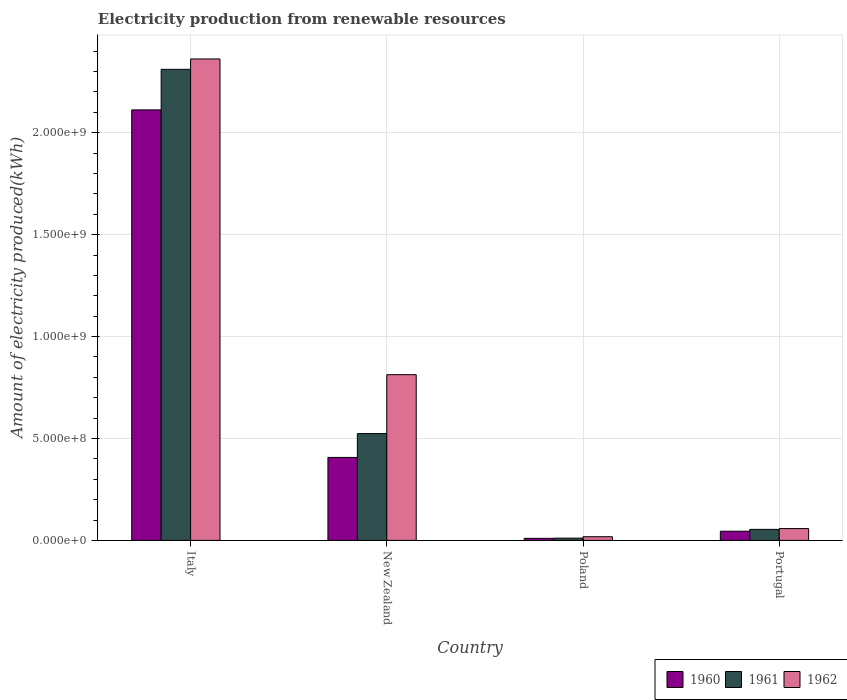How many groups of bars are there?
Offer a terse response. 4. Are the number of bars per tick equal to the number of legend labels?
Make the answer very short. Yes. How many bars are there on the 3rd tick from the left?
Keep it short and to the point. 3. How many bars are there on the 1st tick from the right?
Make the answer very short. 3. What is the label of the 2nd group of bars from the left?
Offer a very short reply. New Zealand. What is the amount of electricity produced in 1960 in Italy?
Give a very brief answer. 2.11e+09. Across all countries, what is the maximum amount of electricity produced in 1961?
Offer a very short reply. 2.31e+09. Across all countries, what is the minimum amount of electricity produced in 1962?
Your response must be concise. 1.80e+07. In which country was the amount of electricity produced in 1961 minimum?
Your answer should be very brief. Poland. What is the total amount of electricity produced in 1960 in the graph?
Your answer should be compact. 2.57e+09. What is the difference between the amount of electricity produced in 1960 in Italy and that in New Zealand?
Give a very brief answer. 1.70e+09. What is the difference between the amount of electricity produced in 1962 in Portugal and the amount of electricity produced in 1960 in Italy?
Keep it short and to the point. -2.05e+09. What is the average amount of electricity produced in 1961 per country?
Keep it short and to the point. 7.25e+08. What is the difference between the amount of electricity produced of/in 1960 and amount of electricity produced of/in 1961 in Italy?
Your answer should be compact. -1.99e+08. In how many countries, is the amount of electricity produced in 1961 greater than 800000000 kWh?
Your response must be concise. 1. What is the ratio of the amount of electricity produced in 1960 in New Zealand to that in Poland?
Ensure brevity in your answer.  40.7. Is the difference between the amount of electricity produced in 1960 in Poland and Portugal greater than the difference between the amount of electricity produced in 1961 in Poland and Portugal?
Provide a short and direct response. Yes. What is the difference between the highest and the second highest amount of electricity produced in 1961?
Your answer should be very brief. 1.79e+09. What is the difference between the highest and the lowest amount of electricity produced in 1961?
Provide a succinct answer. 2.30e+09. How many bars are there?
Your answer should be compact. 12. Are all the bars in the graph horizontal?
Your response must be concise. No. Are the values on the major ticks of Y-axis written in scientific E-notation?
Give a very brief answer. Yes. Does the graph contain any zero values?
Give a very brief answer. No. How are the legend labels stacked?
Make the answer very short. Horizontal. What is the title of the graph?
Make the answer very short. Electricity production from renewable resources. Does "2002" appear as one of the legend labels in the graph?
Your response must be concise. No. What is the label or title of the Y-axis?
Make the answer very short. Amount of electricity produced(kWh). What is the Amount of electricity produced(kWh) in 1960 in Italy?
Your answer should be very brief. 2.11e+09. What is the Amount of electricity produced(kWh) of 1961 in Italy?
Your answer should be very brief. 2.31e+09. What is the Amount of electricity produced(kWh) in 1962 in Italy?
Your answer should be compact. 2.36e+09. What is the Amount of electricity produced(kWh) of 1960 in New Zealand?
Give a very brief answer. 4.07e+08. What is the Amount of electricity produced(kWh) in 1961 in New Zealand?
Provide a short and direct response. 5.24e+08. What is the Amount of electricity produced(kWh) in 1962 in New Zealand?
Provide a succinct answer. 8.13e+08. What is the Amount of electricity produced(kWh) of 1960 in Poland?
Offer a very short reply. 1.00e+07. What is the Amount of electricity produced(kWh) of 1961 in Poland?
Provide a short and direct response. 1.10e+07. What is the Amount of electricity produced(kWh) in 1962 in Poland?
Offer a very short reply. 1.80e+07. What is the Amount of electricity produced(kWh) of 1960 in Portugal?
Make the answer very short. 4.50e+07. What is the Amount of electricity produced(kWh) of 1961 in Portugal?
Provide a short and direct response. 5.40e+07. What is the Amount of electricity produced(kWh) of 1962 in Portugal?
Your answer should be very brief. 5.80e+07. Across all countries, what is the maximum Amount of electricity produced(kWh) in 1960?
Offer a terse response. 2.11e+09. Across all countries, what is the maximum Amount of electricity produced(kWh) in 1961?
Offer a terse response. 2.31e+09. Across all countries, what is the maximum Amount of electricity produced(kWh) of 1962?
Make the answer very short. 2.36e+09. Across all countries, what is the minimum Amount of electricity produced(kWh) of 1961?
Offer a very short reply. 1.10e+07. Across all countries, what is the minimum Amount of electricity produced(kWh) of 1962?
Give a very brief answer. 1.80e+07. What is the total Amount of electricity produced(kWh) in 1960 in the graph?
Make the answer very short. 2.57e+09. What is the total Amount of electricity produced(kWh) of 1961 in the graph?
Keep it short and to the point. 2.90e+09. What is the total Amount of electricity produced(kWh) of 1962 in the graph?
Offer a terse response. 3.25e+09. What is the difference between the Amount of electricity produced(kWh) of 1960 in Italy and that in New Zealand?
Your response must be concise. 1.70e+09. What is the difference between the Amount of electricity produced(kWh) in 1961 in Italy and that in New Zealand?
Provide a short and direct response. 1.79e+09. What is the difference between the Amount of electricity produced(kWh) of 1962 in Italy and that in New Zealand?
Give a very brief answer. 1.55e+09. What is the difference between the Amount of electricity produced(kWh) in 1960 in Italy and that in Poland?
Keep it short and to the point. 2.10e+09. What is the difference between the Amount of electricity produced(kWh) of 1961 in Italy and that in Poland?
Keep it short and to the point. 2.30e+09. What is the difference between the Amount of electricity produced(kWh) in 1962 in Italy and that in Poland?
Provide a short and direct response. 2.34e+09. What is the difference between the Amount of electricity produced(kWh) of 1960 in Italy and that in Portugal?
Make the answer very short. 2.07e+09. What is the difference between the Amount of electricity produced(kWh) of 1961 in Italy and that in Portugal?
Your answer should be very brief. 2.26e+09. What is the difference between the Amount of electricity produced(kWh) in 1962 in Italy and that in Portugal?
Your answer should be compact. 2.30e+09. What is the difference between the Amount of electricity produced(kWh) of 1960 in New Zealand and that in Poland?
Offer a very short reply. 3.97e+08. What is the difference between the Amount of electricity produced(kWh) in 1961 in New Zealand and that in Poland?
Your answer should be compact. 5.13e+08. What is the difference between the Amount of electricity produced(kWh) in 1962 in New Zealand and that in Poland?
Your answer should be compact. 7.95e+08. What is the difference between the Amount of electricity produced(kWh) in 1960 in New Zealand and that in Portugal?
Make the answer very short. 3.62e+08. What is the difference between the Amount of electricity produced(kWh) in 1961 in New Zealand and that in Portugal?
Keep it short and to the point. 4.70e+08. What is the difference between the Amount of electricity produced(kWh) in 1962 in New Zealand and that in Portugal?
Make the answer very short. 7.55e+08. What is the difference between the Amount of electricity produced(kWh) of 1960 in Poland and that in Portugal?
Ensure brevity in your answer.  -3.50e+07. What is the difference between the Amount of electricity produced(kWh) in 1961 in Poland and that in Portugal?
Provide a short and direct response. -4.30e+07. What is the difference between the Amount of electricity produced(kWh) in 1962 in Poland and that in Portugal?
Offer a terse response. -4.00e+07. What is the difference between the Amount of electricity produced(kWh) of 1960 in Italy and the Amount of electricity produced(kWh) of 1961 in New Zealand?
Provide a short and direct response. 1.59e+09. What is the difference between the Amount of electricity produced(kWh) of 1960 in Italy and the Amount of electricity produced(kWh) of 1962 in New Zealand?
Ensure brevity in your answer.  1.30e+09. What is the difference between the Amount of electricity produced(kWh) of 1961 in Italy and the Amount of electricity produced(kWh) of 1962 in New Zealand?
Give a very brief answer. 1.50e+09. What is the difference between the Amount of electricity produced(kWh) in 1960 in Italy and the Amount of electricity produced(kWh) in 1961 in Poland?
Your answer should be compact. 2.10e+09. What is the difference between the Amount of electricity produced(kWh) of 1960 in Italy and the Amount of electricity produced(kWh) of 1962 in Poland?
Give a very brief answer. 2.09e+09. What is the difference between the Amount of electricity produced(kWh) in 1961 in Italy and the Amount of electricity produced(kWh) in 1962 in Poland?
Provide a short and direct response. 2.29e+09. What is the difference between the Amount of electricity produced(kWh) in 1960 in Italy and the Amount of electricity produced(kWh) in 1961 in Portugal?
Your response must be concise. 2.06e+09. What is the difference between the Amount of electricity produced(kWh) in 1960 in Italy and the Amount of electricity produced(kWh) in 1962 in Portugal?
Your answer should be very brief. 2.05e+09. What is the difference between the Amount of electricity produced(kWh) in 1961 in Italy and the Amount of electricity produced(kWh) in 1962 in Portugal?
Provide a succinct answer. 2.25e+09. What is the difference between the Amount of electricity produced(kWh) in 1960 in New Zealand and the Amount of electricity produced(kWh) in 1961 in Poland?
Keep it short and to the point. 3.96e+08. What is the difference between the Amount of electricity produced(kWh) in 1960 in New Zealand and the Amount of electricity produced(kWh) in 1962 in Poland?
Offer a terse response. 3.89e+08. What is the difference between the Amount of electricity produced(kWh) of 1961 in New Zealand and the Amount of electricity produced(kWh) of 1962 in Poland?
Provide a succinct answer. 5.06e+08. What is the difference between the Amount of electricity produced(kWh) in 1960 in New Zealand and the Amount of electricity produced(kWh) in 1961 in Portugal?
Provide a succinct answer. 3.53e+08. What is the difference between the Amount of electricity produced(kWh) of 1960 in New Zealand and the Amount of electricity produced(kWh) of 1962 in Portugal?
Your answer should be very brief. 3.49e+08. What is the difference between the Amount of electricity produced(kWh) of 1961 in New Zealand and the Amount of electricity produced(kWh) of 1962 in Portugal?
Offer a terse response. 4.66e+08. What is the difference between the Amount of electricity produced(kWh) in 1960 in Poland and the Amount of electricity produced(kWh) in 1961 in Portugal?
Provide a succinct answer. -4.40e+07. What is the difference between the Amount of electricity produced(kWh) in 1960 in Poland and the Amount of electricity produced(kWh) in 1962 in Portugal?
Your response must be concise. -4.80e+07. What is the difference between the Amount of electricity produced(kWh) in 1961 in Poland and the Amount of electricity produced(kWh) in 1962 in Portugal?
Offer a terse response. -4.70e+07. What is the average Amount of electricity produced(kWh) in 1960 per country?
Provide a short and direct response. 6.44e+08. What is the average Amount of electricity produced(kWh) of 1961 per country?
Your answer should be compact. 7.25e+08. What is the average Amount of electricity produced(kWh) of 1962 per country?
Keep it short and to the point. 8.13e+08. What is the difference between the Amount of electricity produced(kWh) of 1960 and Amount of electricity produced(kWh) of 1961 in Italy?
Offer a terse response. -1.99e+08. What is the difference between the Amount of electricity produced(kWh) in 1960 and Amount of electricity produced(kWh) in 1962 in Italy?
Provide a succinct answer. -2.50e+08. What is the difference between the Amount of electricity produced(kWh) in 1961 and Amount of electricity produced(kWh) in 1962 in Italy?
Your response must be concise. -5.10e+07. What is the difference between the Amount of electricity produced(kWh) of 1960 and Amount of electricity produced(kWh) of 1961 in New Zealand?
Provide a succinct answer. -1.17e+08. What is the difference between the Amount of electricity produced(kWh) in 1960 and Amount of electricity produced(kWh) in 1962 in New Zealand?
Ensure brevity in your answer.  -4.06e+08. What is the difference between the Amount of electricity produced(kWh) in 1961 and Amount of electricity produced(kWh) in 1962 in New Zealand?
Your answer should be very brief. -2.89e+08. What is the difference between the Amount of electricity produced(kWh) in 1960 and Amount of electricity produced(kWh) in 1962 in Poland?
Offer a terse response. -8.00e+06. What is the difference between the Amount of electricity produced(kWh) in 1961 and Amount of electricity produced(kWh) in 1962 in Poland?
Provide a succinct answer. -7.00e+06. What is the difference between the Amount of electricity produced(kWh) in 1960 and Amount of electricity produced(kWh) in 1961 in Portugal?
Offer a terse response. -9.00e+06. What is the difference between the Amount of electricity produced(kWh) in 1960 and Amount of electricity produced(kWh) in 1962 in Portugal?
Ensure brevity in your answer.  -1.30e+07. What is the difference between the Amount of electricity produced(kWh) in 1961 and Amount of electricity produced(kWh) in 1962 in Portugal?
Provide a short and direct response. -4.00e+06. What is the ratio of the Amount of electricity produced(kWh) of 1960 in Italy to that in New Zealand?
Give a very brief answer. 5.19. What is the ratio of the Amount of electricity produced(kWh) of 1961 in Italy to that in New Zealand?
Offer a terse response. 4.41. What is the ratio of the Amount of electricity produced(kWh) of 1962 in Italy to that in New Zealand?
Provide a succinct answer. 2.91. What is the ratio of the Amount of electricity produced(kWh) of 1960 in Italy to that in Poland?
Keep it short and to the point. 211.2. What is the ratio of the Amount of electricity produced(kWh) in 1961 in Italy to that in Poland?
Give a very brief answer. 210.09. What is the ratio of the Amount of electricity produced(kWh) of 1962 in Italy to that in Poland?
Provide a short and direct response. 131.22. What is the ratio of the Amount of electricity produced(kWh) in 1960 in Italy to that in Portugal?
Offer a very short reply. 46.93. What is the ratio of the Amount of electricity produced(kWh) of 1961 in Italy to that in Portugal?
Make the answer very short. 42.8. What is the ratio of the Amount of electricity produced(kWh) in 1962 in Italy to that in Portugal?
Make the answer very short. 40.72. What is the ratio of the Amount of electricity produced(kWh) in 1960 in New Zealand to that in Poland?
Provide a succinct answer. 40.7. What is the ratio of the Amount of electricity produced(kWh) in 1961 in New Zealand to that in Poland?
Ensure brevity in your answer.  47.64. What is the ratio of the Amount of electricity produced(kWh) of 1962 in New Zealand to that in Poland?
Your answer should be compact. 45.17. What is the ratio of the Amount of electricity produced(kWh) in 1960 in New Zealand to that in Portugal?
Keep it short and to the point. 9.04. What is the ratio of the Amount of electricity produced(kWh) in 1961 in New Zealand to that in Portugal?
Your response must be concise. 9.7. What is the ratio of the Amount of electricity produced(kWh) of 1962 in New Zealand to that in Portugal?
Offer a very short reply. 14.02. What is the ratio of the Amount of electricity produced(kWh) in 1960 in Poland to that in Portugal?
Provide a short and direct response. 0.22. What is the ratio of the Amount of electricity produced(kWh) of 1961 in Poland to that in Portugal?
Your response must be concise. 0.2. What is the ratio of the Amount of electricity produced(kWh) in 1962 in Poland to that in Portugal?
Your answer should be compact. 0.31. What is the difference between the highest and the second highest Amount of electricity produced(kWh) in 1960?
Keep it short and to the point. 1.70e+09. What is the difference between the highest and the second highest Amount of electricity produced(kWh) of 1961?
Your response must be concise. 1.79e+09. What is the difference between the highest and the second highest Amount of electricity produced(kWh) in 1962?
Ensure brevity in your answer.  1.55e+09. What is the difference between the highest and the lowest Amount of electricity produced(kWh) in 1960?
Keep it short and to the point. 2.10e+09. What is the difference between the highest and the lowest Amount of electricity produced(kWh) in 1961?
Ensure brevity in your answer.  2.30e+09. What is the difference between the highest and the lowest Amount of electricity produced(kWh) of 1962?
Ensure brevity in your answer.  2.34e+09. 